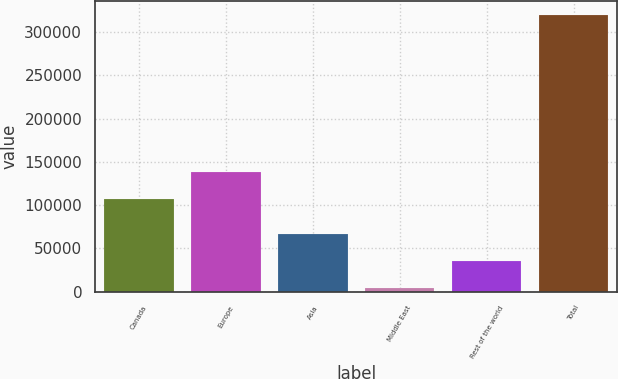Convert chart. <chart><loc_0><loc_0><loc_500><loc_500><bar_chart><fcel>Canada<fcel>Europe<fcel>Asia<fcel>Middle East<fcel>Rest of the world<fcel>Total<nl><fcel>106598<fcel>138217<fcel>67062.6<fcel>3824<fcel>35443.3<fcel>320017<nl></chart> 